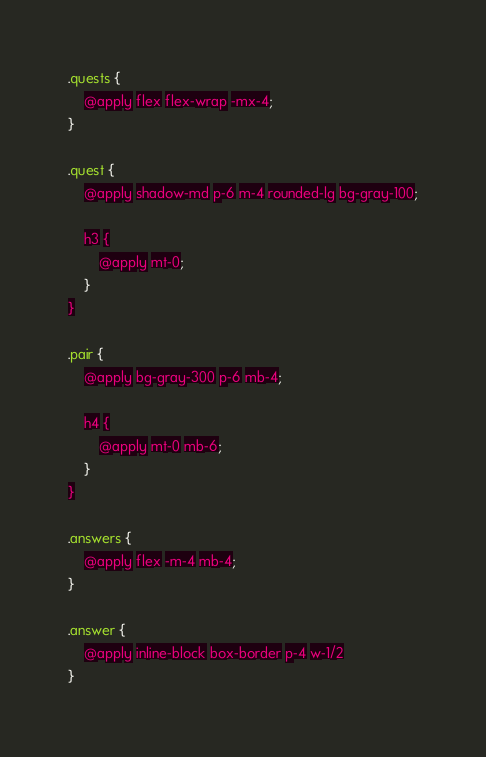Convert code to text. <code><loc_0><loc_0><loc_500><loc_500><_CSS_>.quests {
    @apply flex flex-wrap -mx-4;
}

.quest {
    @apply shadow-md p-6 m-4 rounded-lg bg-gray-100;

    h3 {
        @apply mt-0;
    }
}

.pair {
    @apply bg-gray-300 p-6 mb-4;

    h4 {
        @apply mt-0 mb-6;
    }
}

.answers {
    @apply flex -m-4 mb-4;
}

.answer {
    @apply inline-block box-border p-4 w-1/2
}
</code> 